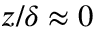<formula> <loc_0><loc_0><loc_500><loc_500>z / \delta \approx 0</formula> 